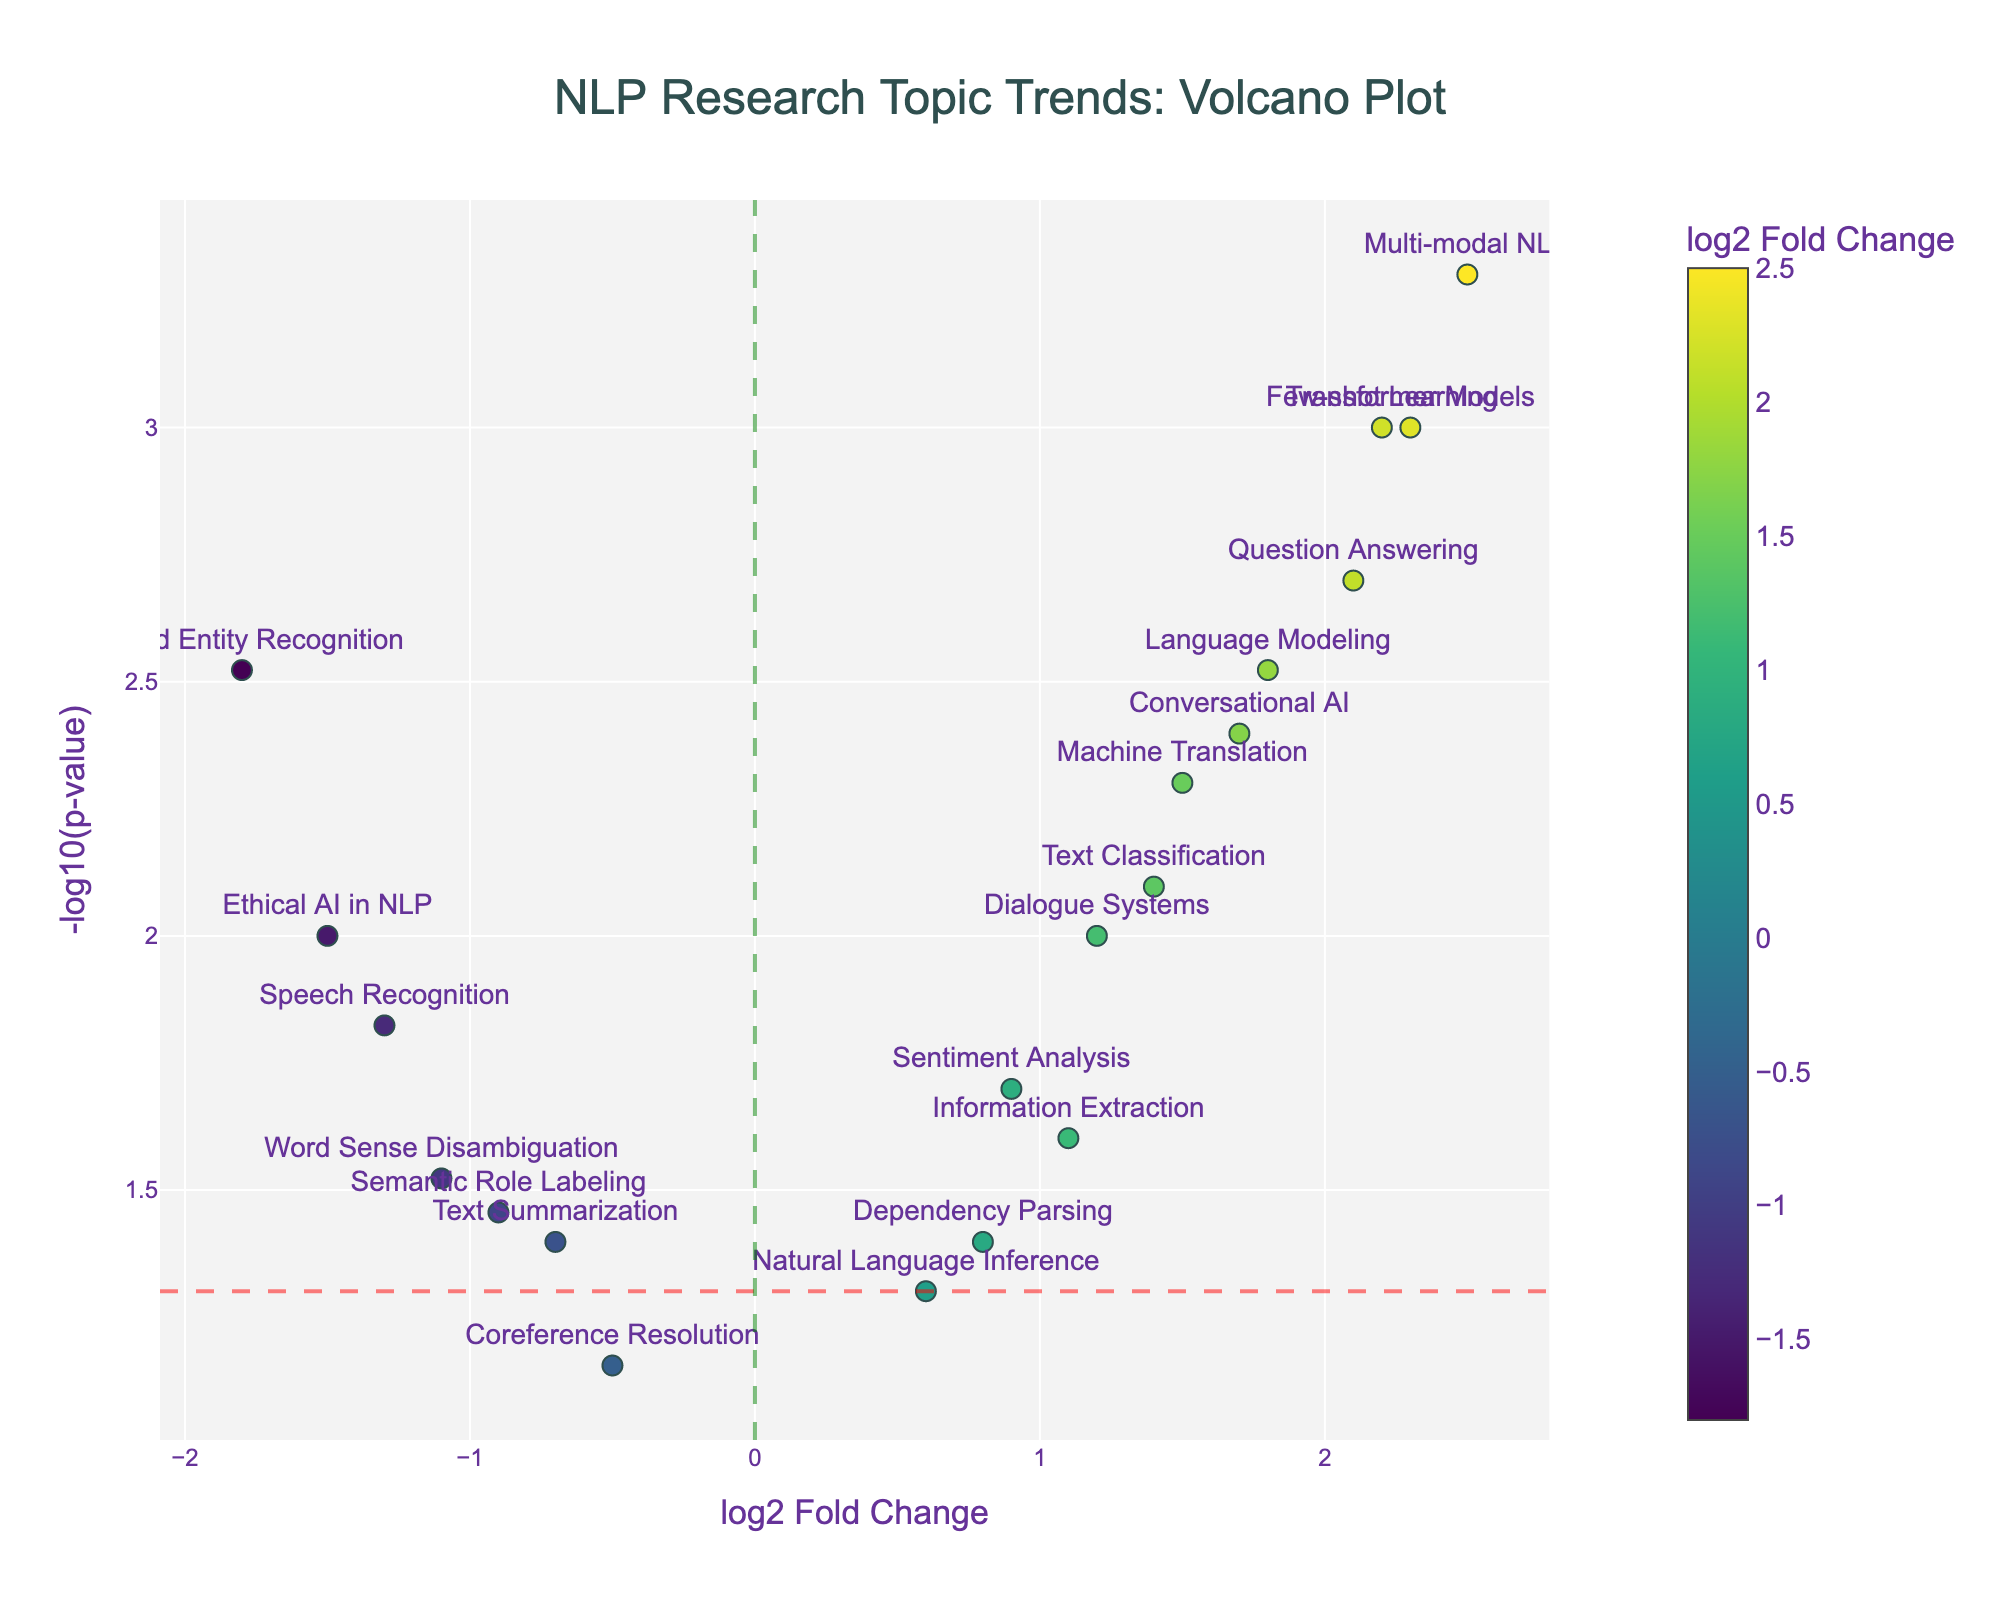What is the title of this plot? The title appears near the top center of the figure. By reading the text there, you can see it says: "NLP Research Topic Trends: Volcano Plot".
Answer: NLP Research Topic Trends: Volcano Plot How many research topics are plotted in the figure? Each marker represents a research topic, indicated by text labels. Counting these labels, we find there are 20 research topics in the plot.
Answer: 20 Which research topic shows the highest log2 Fold Change? The highest log2 Fold Change can be identified by looking at the marker farthest to the right on the x-axis. This marker is labeled "Multi-modal NLP".
Answer: Multi-modal NLP What is the -log10(p-value) for the topic "Machine Translation"? To find this, locate the "Machine Translation" marker and observe its y-axis value. For this topic, the -log10(p-value) is approximately -log10(0.005), which corresponds to roughly 2.30.
Answer: 2.30 Which topics have the lowest -log10(p-value)? The lowest -log10(p-value) corresponds to the highest p-value. Look for the marker closest to the bottom of the y-axis. "Coreference Resolution" and "Natural Language Inference" have the lowest value, which is -log10(0.07) ≈ 1.15 and -log10(0.05) = 1.30 respectively.
Answer: Coreference Resolution, Natural Language Inference How does the significance of "Transformer Models" compare to "Ethical AI in NLP"? Compare the y-axis positions (-log10(p-value)) of the two topics. "Transformer Models" is higher on the y-axis, indicating a more significant p-value since its -log10(p-value) is higher than that of "Ethical AI in NLP".
Answer: Transformer Models has a higher -log10(p-value) What can be inferred about topics located to the left of the green vertical line? Topics to the left of the green vertical line have a negative log2 Fold Change, indicating a decrease in their trend over time.
Answer: Decreasing trend Which topics are significantly trending (p < 0.05)? Topics with markers above the horizontal red dashed line have p-values less than 0.05. These include: Transformer Models, Named Entity Recognition, Machine Translation, Question Answering, Dialogue Systems, Language Modeling, Speech Recognition, Information Extraction, Text Classification, Few-shot Learning, and Conversational AI.
Answer: Transformer Models, Named Entity Recognition, Machine Translation, Question Answering, Dialogue Systems, Language Modeling, Speech Recognition, Information Extraction, Text Classification, Few-shot Learning, Conversational AI 